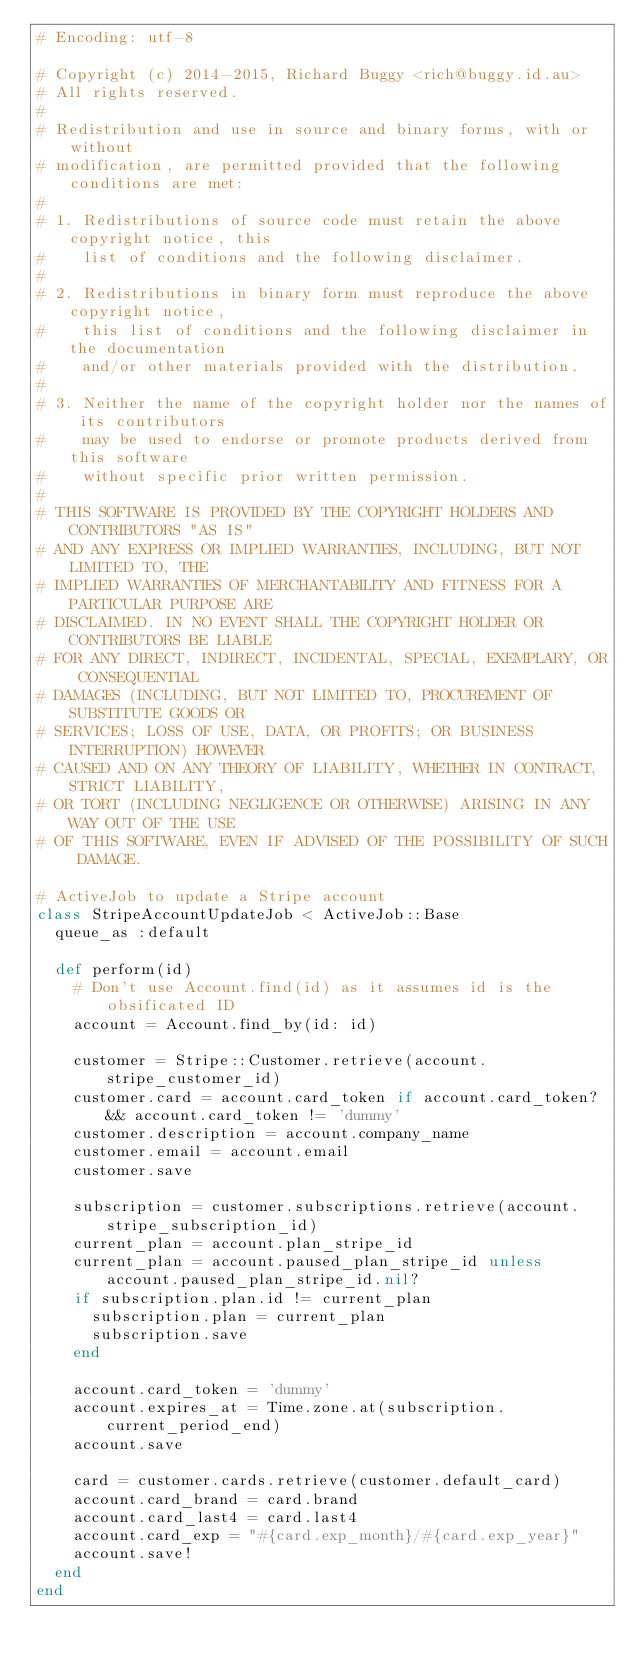<code> <loc_0><loc_0><loc_500><loc_500><_Ruby_># Encoding: utf-8

# Copyright (c) 2014-2015, Richard Buggy <rich@buggy.id.au>
# All rights reserved.
#
# Redistribution and use in source and binary forms, with or without
# modification, are permitted provided that the following conditions are met:
#
# 1. Redistributions of source code must retain the above copyright notice, this
#    list of conditions and the following disclaimer.
#
# 2. Redistributions in binary form must reproduce the above copyright notice,
#    this list of conditions and the following disclaimer in the documentation
#    and/or other materials provided with the distribution.
#
# 3. Neither the name of the copyright holder nor the names of its contributors
#    may be used to endorse or promote products derived from this software
#    without specific prior written permission.
#
# THIS SOFTWARE IS PROVIDED BY THE COPYRIGHT HOLDERS AND CONTRIBUTORS "AS IS"
# AND ANY EXPRESS OR IMPLIED WARRANTIES, INCLUDING, BUT NOT LIMITED TO, THE
# IMPLIED WARRANTIES OF MERCHANTABILITY AND FITNESS FOR A PARTICULAR PURPOSE ARE
# DISCLAIMED. IN NO EVENT SHALL THE COPYRIGHT HOLDER OR CONTRIBUTORS BE LIABLE
# FOR ANY DIRECT, INDIRECT, INCIDENTAL, SPECIAL, EXEMPLARY, OR CONSEQUENTIAL
# DAMAGES (INCLUDING, BUT NOT LIMITED TO, PROCUREMENT OF SUBSTITUTE GOODS OR
# SERVICES; LOSS OF USE, DATA, OR PROFITS; OR BUSINESS INTERRUPTION) HOWEVER
# CAUSED AND ON ANY THEORY OF LIABILITY, WHETHER IN CONTRACT, STRICT LIABILITY,
# OR TORT (INCLUDING NEGLIGENCE OR OTHERWISE) ARISING IN ANY WAY OUT OF THE USE
# OF THIS SOFTWARE, EVEN IF ADVISED OF THE POSSIBILITY OF SUCH DAMAGE.

# ActiveJob to update a Stripe account
class StripeAccountUpdateJob < ActiveJob::Base
  queue_as :default

  def perform(id)
    # Don't use Account.find(id) as it assumes id is the obsificated ID
    account = Account.find_by(id: id)

    customer = Stripe::Customer.retrieve(account.stripe_customer_id)
    customer.card = account.card_token if account.card_token? && account.card_token != 'dummy'
    customer.description = account.company_name
    customer.email = account.email
    customer.save

    subscription = customer.subscriptions.retrieve(account.stripe_subscription_id)
    current_plan = account.plan_stripe_id
    current_plan = account.paused_plan_stripe_id unless account.paused_plan_stripe_id.nil?
    if subscription.plan.id != current_plan
      subscription.plan = current_plan
      subscription.save
    end

    account.card_token = 'dummy'
    account.expires_at = Time.zone.at(subscription.current_period_end)
    account.save

    card = customer.cards.retrieve(customer.default_card)
    account.card_brand = card.brand
    account.card_last4 = card.last4
    account.card_exp = "#{card.exp_month}/#{card.exp_year}"
    account.save!
  end
end
</code> 